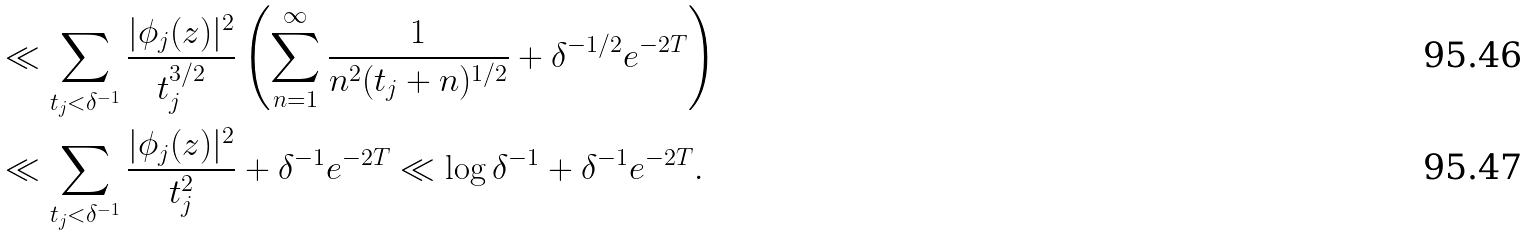<formula> <loc_0><loc_0><loc_500><loc_500>& \ll \sum _ { t _ { j } < \delta ^ { - 1 } } \frac { | \phi _ { j } ( z ) | ^ { 2 } } { t _ { j } ^ { 3 / 2 } } \left ( \sum _ { n = 1 } ^ { \infty } \frac { 1 } { n ^ { 2 } ( t _ { j } + n ) ^ { 1 / 2 } } + \delta ^ { - 1 / 2 } e ^ { - 2 T } \right ) \\ & \ll \sum _ { t _ { j } < \delta ^ { - 1 } } \frac { | \phi _ { j } ( z ) | ^ { 2 } } { t _ { j } ^ { 2 } } + \delta ^ { - 1 } e ^ { - 2 T } \ll \log \delta ^ { - 1 } + \delta ^ { - 1 } e ^ { - 2 T } .</formula> 